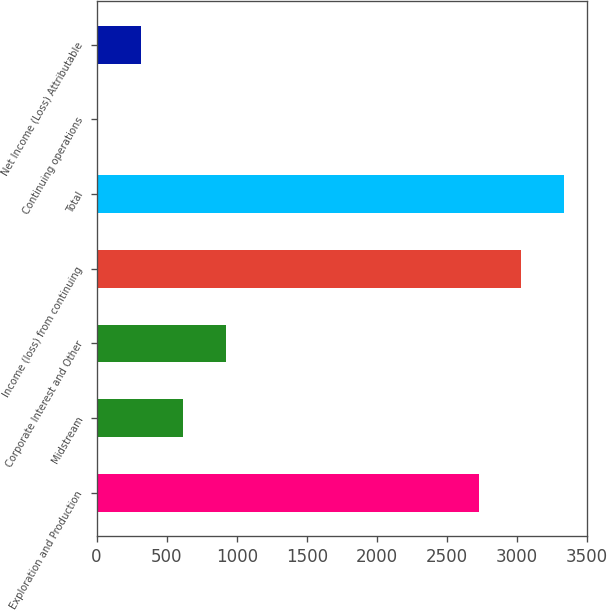Convert chart. <chart><loc_0><loc_0><loc_500><loc_500><bar_chart><fcel>Exploration and Production<fcel>Midstream<fcel>Corporate Interest and Other<fcel>Income (loss) from continuing<fcel>Total<fcel>Continuing operations<fcel>Net Income (Loss) Attributable<nl><fcel>2727<fcel>619.69<fcel>924.23<fcel>3031.54<fcel>3336.08<fcel>10.61<fcel>315.15<nl></chart> 